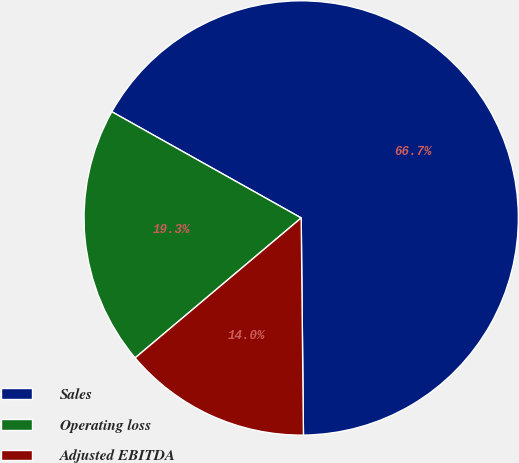Convert chart to OTSL. <chart><loc_0><loc_0><loc_500><loc_500><pie_chart><fcel>Sales<fcel>Operating loss<fcel>Adjusted EBITDA<nl><fcel>66.7%<fcel>19.28%<fcel>14.02%<nl></chart> 